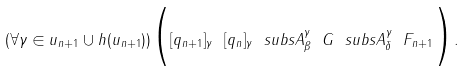<formula> <loc_0><loc_0><loc_500><loc_500>( \forall \gamma \in u _ { n + 1 } \cup h ( u _ { n + 1 } ) ) \Big { ( } [ q _ { n + 1 } ] _ { \gamma } \ [ q _ { n } ] _ { \gamma } \ s u b s A ^ { \gamma } _ { \beta } \ G \ s u b s A ^ { \gamma } _ { \delta } \ F _ { n + 1 } \Big { ) } .</formula> 